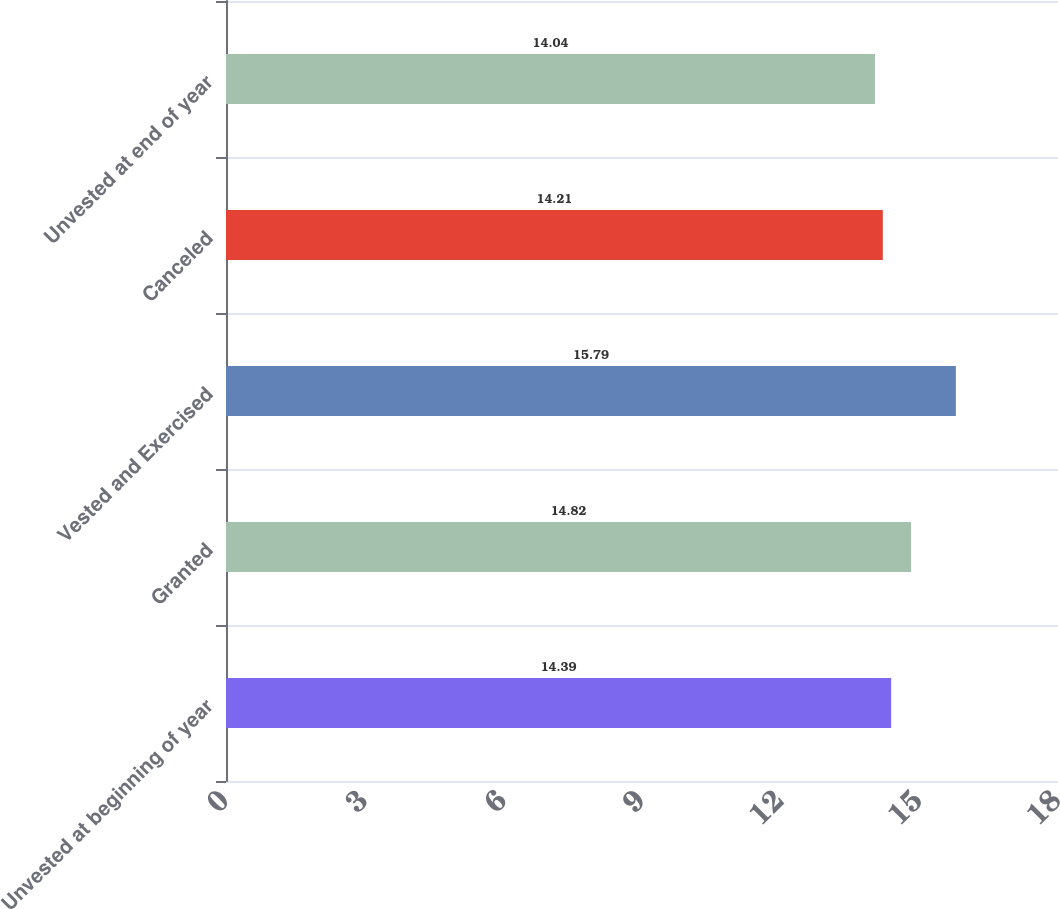Convert chart. <chart><loc_0><loc_0><loc_500><loc_500><bar_chart><fcel>Unvested at beginning of year<fcel>Granted<fcel>Vested and Exercised<fcel>Canceled<fcel>Unvested at end of year<nl><fcel>14.39<fcel>14.82<fcel>15.79<fcel>14.21<fcel>14.04<nl></chart> 